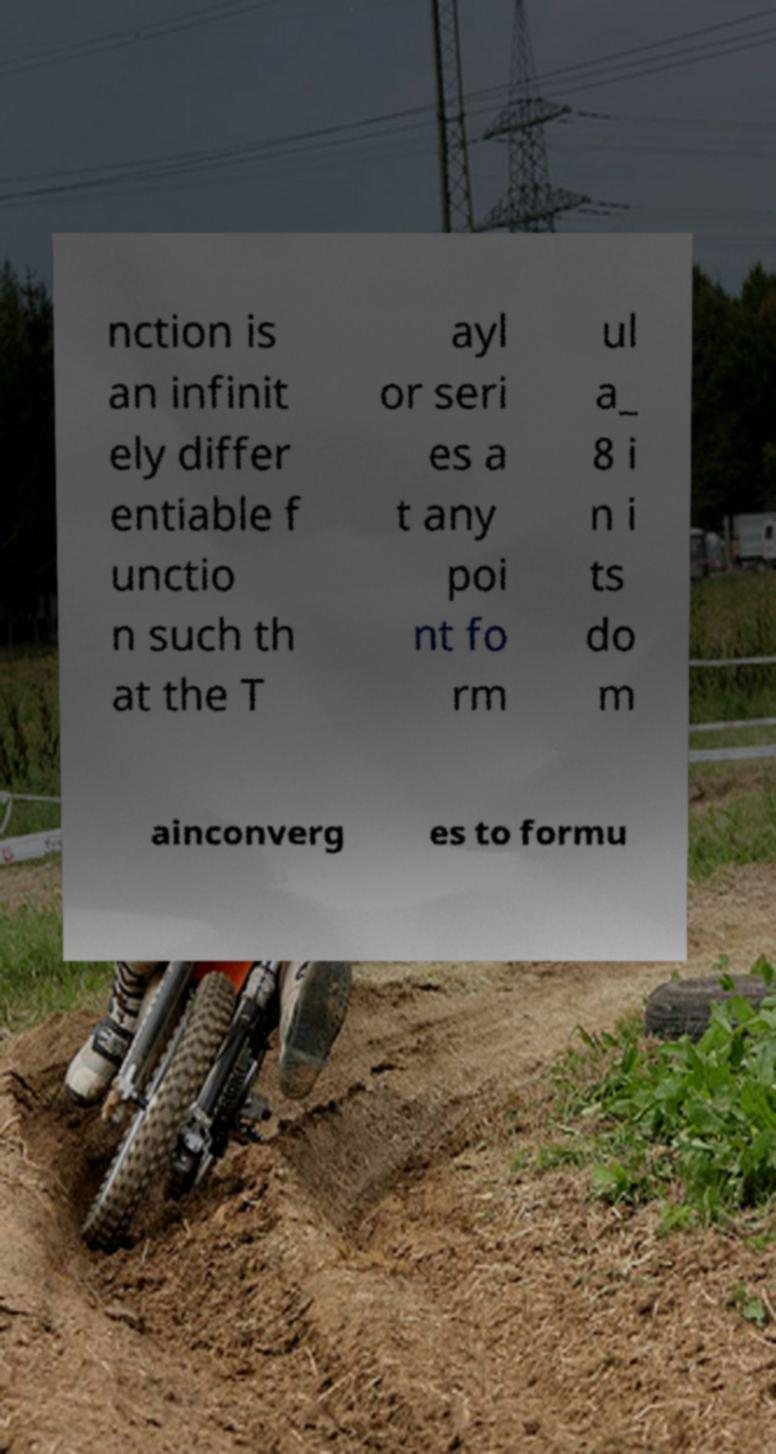I need the written content from this picture converted into text. Can you do that? nction is an infinit ely differ entiable f unctio n such th at the T ayl or seri es a t any poi nt fo rm ul a_ 8 i n i ts do m ainconverg es to formu 